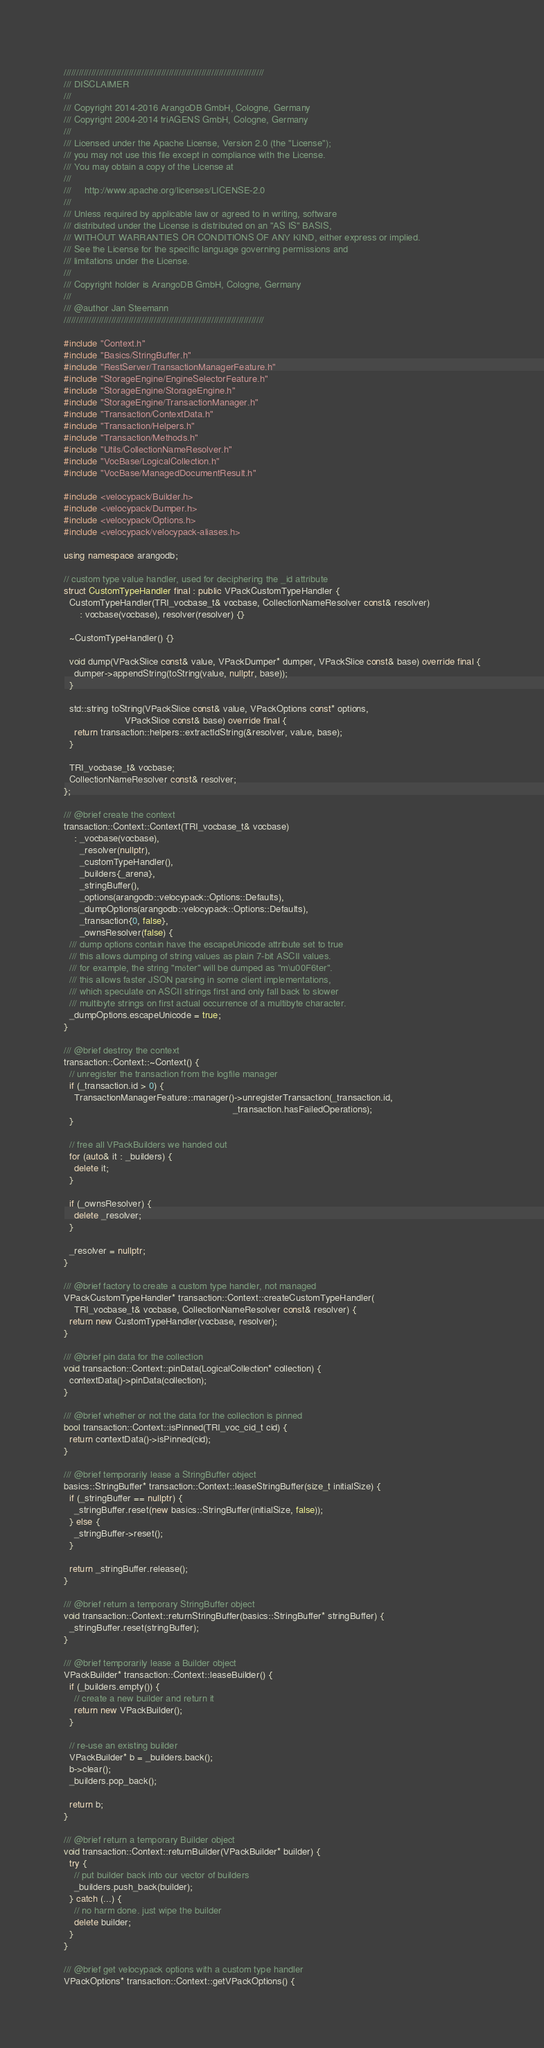Convert code to text. <code><loc_0><loc_0><loc_500><loc_500><_C++_>////////////////////////////////////////////////////////////////////////////////
/// DISCLAIMER
///
/// Copyright 2014-2016 ArangoDB GmbH, Cologne, Germany
/// Copyright 2004-2014 triAGENS GmbH, Cologne, Germany
///
/// Licensed under the Apache License, Version 2.0 (the "License");
/// you may not use this file except in compliance with the License.
/// You may obtain a copy of the License at
///
///     http://www.apache.org/licenses/LICENSE-2.0
///
/// Unless required by applicable law or agreed to in writing, software
/// distributed under the License is distributed on an "AS IS" BASIS,
/// WITHOUT WARRANTIES OR CONDITIONS OF ANY KIND, either express or implied.
/// See the License for the specific language governing permissions and
/// limitations under the License.
///
/// Copyright holder is ArangoDB GmbH, Cologne, Germany
///
/// @author Jan Steemann
////////////////////////////////////////////////////////////////////////////////

#include "Context.h"
#include "Basics/StringBuffer.h"
#include "RestServer/TransactionManagerFeature.h"
#include "StorageEngine/EngineSelectorFeature.h"
#include "StorageEngine/StorageEngine.h"
#include "StorageEngine/TransactionManager.h"
#include "Transaction/ContextData.h"
#include "Transaction/Helpers.h"
#include "Transaction/Methods.h"
#include "Utils/CollectionNameResolver.h"
#include "VocBase/LogicalCollection.h"
#include "VocBase/ManagedDocumentResult.h"

#include <velocypack/Builder.h>
#include <velocypack/Dumper.h>
#include <velocypack/Options.h>
#include <velocypack/velocypack-aliases.h>

using namespace arangodb;

// custom type value handler, used for deciphering the _id attribute
struct CustomTypeHandler final : public VPackCustomTypeHandler {
  CustomTypeHandler(TRI_vocbase_t& vocbase, CollectionNameResolver const& resolver)
      : vocbase(vocbase), resolver(resolver) {}

  ~CustomTypeHandler() {}

  void dump(VPackSlice const& value, VPackDumper* dumper, VPackSlice const& base) override final {
    dumper->appendString(toString(value, nullptr, base));
  }

  std::string toString(VPackSlice const& value, VPackOptions const* options,
                       VPackSlice const& base) override final {
    return transaction::helpers::extractIdString(&resolver, value, base);
  }

  TRI_vocbase_t& vocbase;
  CollectionNameResolver const& resolver;
};

/// @brief create the context
transaction::Context::Context(TRI_vocbase_t& vocbase)
    : _vocbase(vocbase),
      _resolver(nullptr),
      _customTypeHandler(),
      _builders{_arena},
      _stringBuffer(),
      _options(arangodb::velocypack::Options::Defaults),
      _dumpOptions(arangodb::velocypack::Options::Defaults),
      _transaction{0, false},
      _ownsResolver(false) {
  /// dump options contain have the escapeUnicode attribute set to true
  /// this allows dumping of string values as plain 7-bit ASCII values.
  /// for example, the string "möter" will be dumped as "m\u00F6ter".
  /// this allows faster JSON parsing in some client implementations,
  /// which speculate on ASCII strings first and only fall back to slower
  /// multibyte strings on first actual occurrence of a multibyte character.
  _dumpOptions.escapeUnicode = true;
}

/// @brief destroy the context
transaction::Context::~Context() {
  // unregister the transaction from the logfile manager
  if (_transaction.id > 0) {
    TransactionManagerFeature::manager()->unregisterTransaction(_transaction.id,
                                                                _transaction.hasFailedOperations);
  }

  // free all VPackBuilders we handed out
  for (auto& it : _builders) {
    delete it;
  }

  if (_ownsResolver) {
    delete _resolver;
  }

  _resolver = nullptr;
}

/// @brief factory to create a custom type handler, not managed
VPackCustomTypeHandler* transaction::Context::createCustomTypeHandler(
    TRI_vocbase_t& vocbase, CollectionNameResolver const& resolver) {
  return new CustomTypeHandler(vocbase, resolver);
}

/// @brief pin data for the collection
void transaction::Context::pinData(LogicalCollection* collection) {
  contextData()->pinData(collection);
}

/// @brief whether or not the data for the collection is pinned
bool transaction::Context::isPinned(TRI_voc_cid_t cid) {
  return contextData()->isPinned(cid);
}

/// @brief temporarily lease a StringBuffer object
basics::StringBuffer* transaction::Context::leaseStringBuffer(size_t initialSize) {
  if (_stringBuffer == nullptr) {
    _stringBuffer.reset(new basics::StringBuffer(initialSize, false));
  } else {
    _stringBuffer->reset();
  }

  return _stringBuffer.release();
}

/// @brief return a temporary StringBuffer object
void transaction::Context::returnStringBuffer(basics::StringBuffer* stringBuffer) {
  _stringBuffer.reset(stringBuffer);
}

/// @brief temporarily lease a Builder object
VPackBuilder* transaction::Context::leaseBuilder() {
  if (_builders.empty()) {
    // create a new builder and return it
    return new VPackBuilder();
  }

  // re-use an existing builder
  VPackBuilder* b = _builders.back();
  b->clear();
  _builders.pop_back();

  return b;
}

/// @brief return a temporary Builder object
void transaction::Context::returnBuilder(VPackBuilder* builder) {
  try {
    // put builder back into our vector of builders
    _builders.push_back(builder);
  } catch (...) {
    // no harm done. just wipe the builder
    delete builder;
  }
}

/// @brief get velocypack options with a custom type handler
VPackOptions* transaction::Context::getVPackOptions() {</code> 